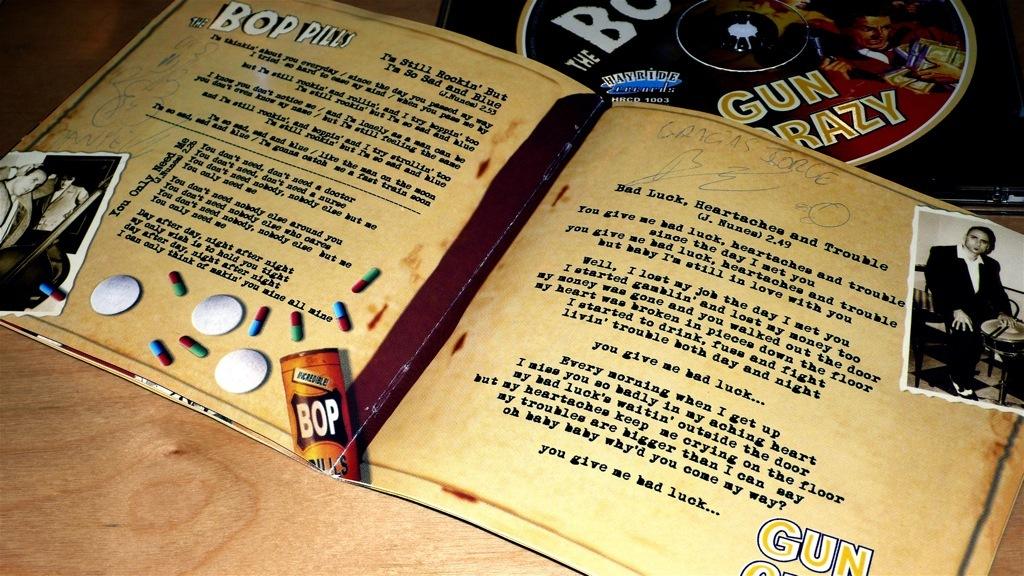What does the word written in white say on the very top left of the book?
Offer a terse response. Bop pills. 